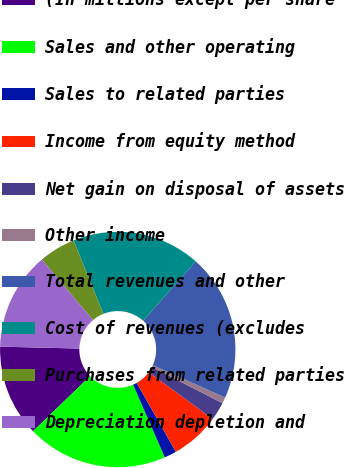Convert chart. <chart><loc_0><loc_0><loc_500><loc_500><pie_chart><fcel>(In millions except per share<fcel>Sales and other operating<fcel>Sales to related parties<fcel>Income from equity method<fcel>Net gain on disposal of assets<fcel>Other income<fcel>Total revenues and other<fcel>Cost of revenues (excludes<fcel>Purchases from related parties<fcel>Depreciation depletion and<nl><fcel>12.6%<fcel>19.33%<fcel>1.68%<fcel>6.72%<fcel>2.52%<fcel>0.84%<fcel>20.17%<fcel>17.65%<fcel>5.04%<fcel>13.45%<nl></chart> 